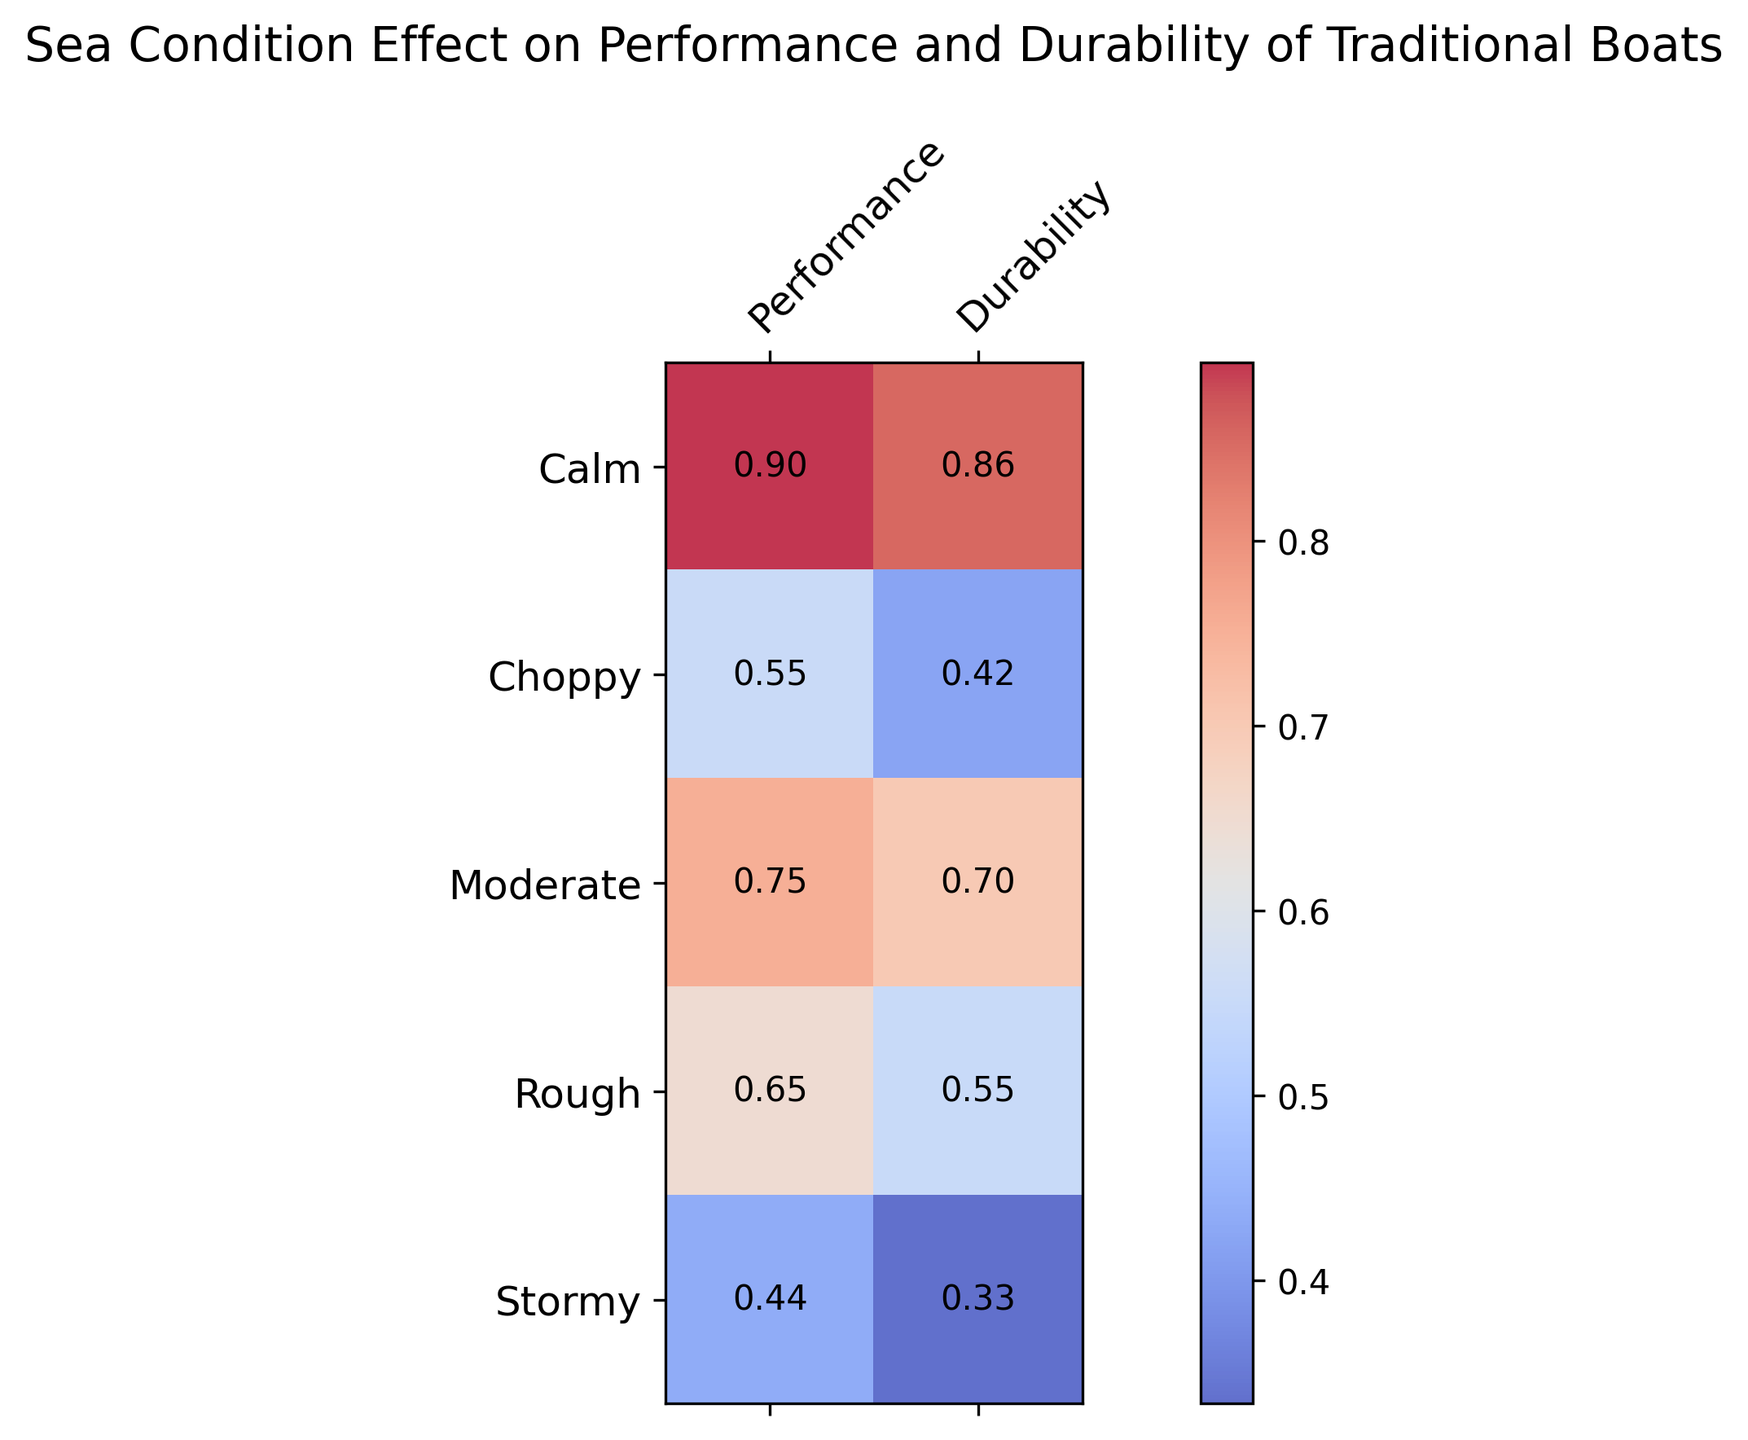What sea condition has the highest average performance? Calm sea conditions show the highest values in the performance column, as evidenced by the numbers given in the heatmap.
Answer: Calm Which sea condition has the lowest average durability? Stormy sea conditions show the lowest values in the durability column of the heatmap.
Answer: Stormy Compare the performance under Moderate and Choppy sea conditions. Which is better? The heatmap shows that the performance under Moderate conditions is around 0.75, 0.78, and 0.73, averaging to about 0.75, while under Choppy conditions it's about 0.55, 0.58, and 0.53, averaging to around 0.55.
Answer: Moderate What is the difference in average durability between Calm and Rough sea conditions? The average durability in Calm conditions is approximately (0.85 + 0.88 + 0.84) / 3 = 0.8567 and in Rough conditions it is approximately (0.55 + 0.57 + 0.53) / 3 = 0.55. The difference is approximately 0.8567 - 0.55 = 0.3067.
Answer: 0.3067 In which sea condition do you observe the largest drop in performance compared to Calm conditions? By comparing, the average performance under Calm conditions is around 0.8967 (approx) while under Stormy conditions it is around 0.437 (approx). This drop of around 0.459 is the largest.
Answer: Stormy Which sea conditions show a performance less than 0.6? From the heatmap, Choppy (0.55, 0.58, 0.53) and Stormy (0.45, 0.42, 0.44) conditions show performance values less than 0.6.
Answer: Choppy, Stormy What is the sum of the average performance and average durability for Rough sea conditions? The average performance for Rough is (0.65 + 0.66 + 0.63) / 3 = 0.6467 and the average durability is (0.55 + 0.57 + 0.53) / 3 = 0.55. Summing these gives 0.6467 + 0.55 = 1.1967.
Answer: 1.1967 How does the intensity of the color relate to the values in the heatmap? The color intensity follows the values with darker areas representing lower values and lighter areas representing higher values. For instance, Calm conditions have lighter shades while Stormy has darker ones, indicating their respective higher and lower values.
Answer: Darker for lower values, lighter for higher values Under which condition is the average durability closest to 0.7? The average durability under Moderate conditions is around 0.7, as seen in the heatmap through its positioning in the second row and slightly darker hue.
Answer: Moderate How does durability change from Moderate to Rough sea conditions? The change can be seen as a decrease, where Moderate has an average around 0.7 and Rough has an average around 0.55, showing a decline.
Answer: Decreases 